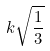<formula> <loc_0><loc_0><loc_500><loc_500>k \sqrt { \frac { 1 } { 3 } }</formula> 